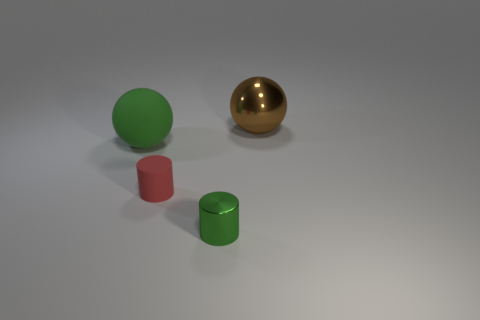Add 3 large green matte spheres. How many objects exist? 7 Subtract 0 purple blocks. How many objects are left? 4 Subtract all green cylinders. Subtract all red balls. How many cylinders are left? 1 Subtract all big metallic things. Subtract all rubber cylinders. How many objects are left? 2 Add 2 cylinders. How many cylinders are left? 4 Add 2 rubber things. How many rubber things exist? 4 